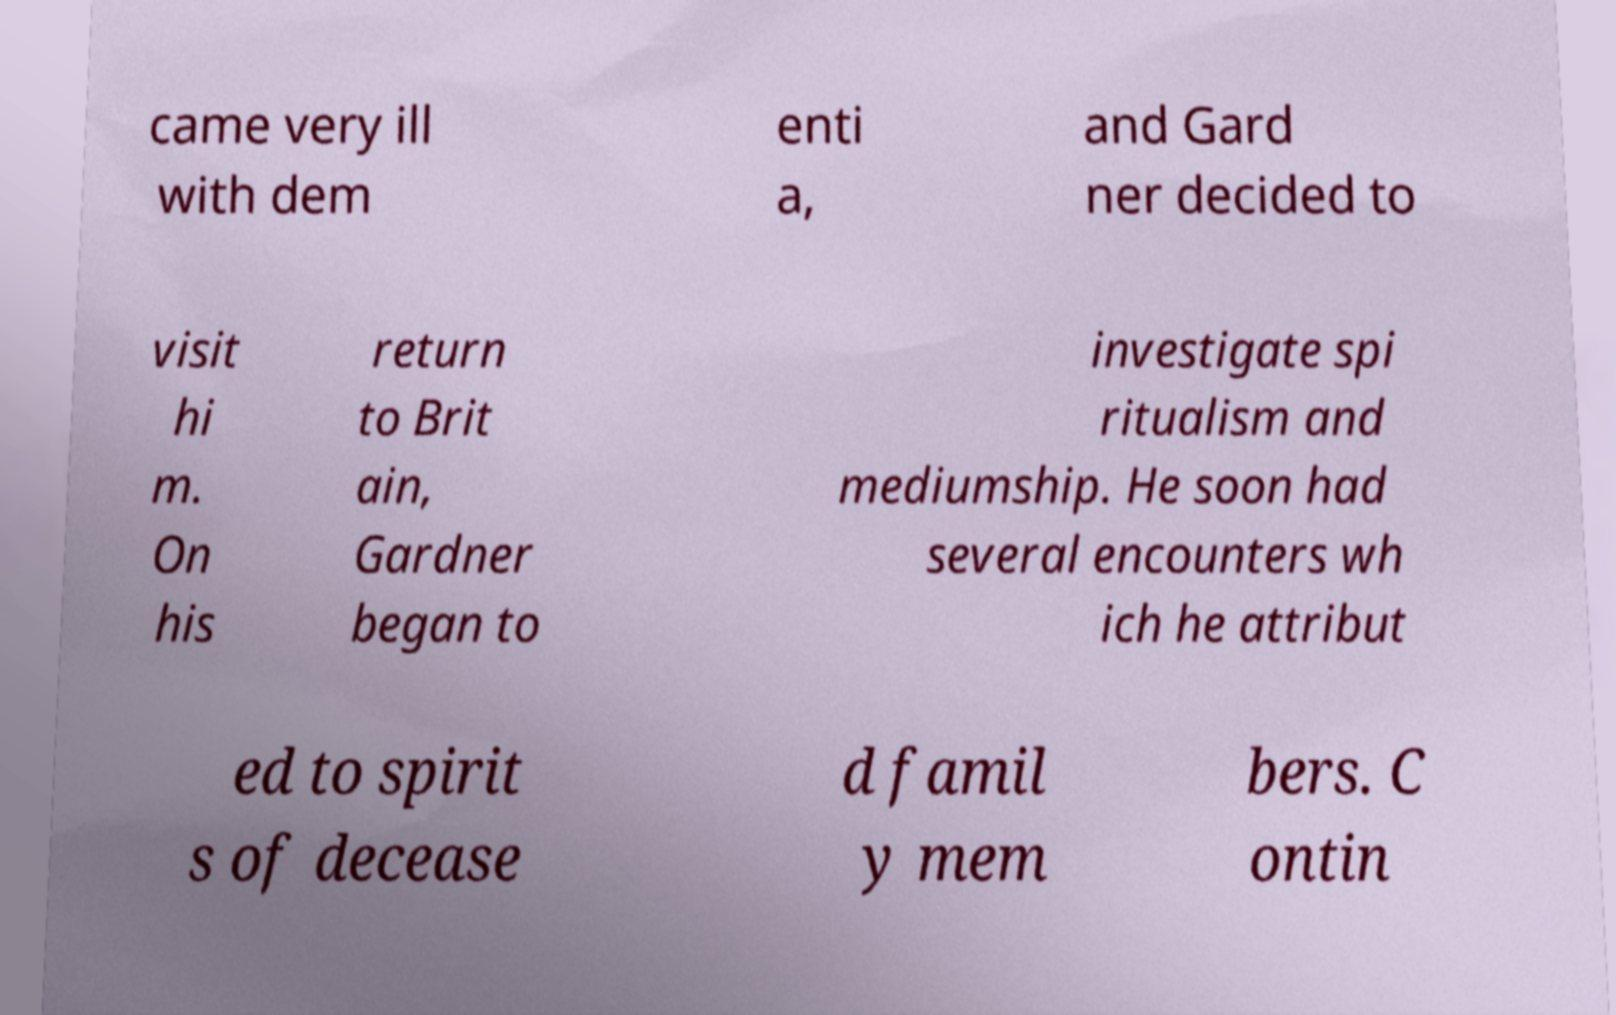For documentation purposes, I need the text within this image transcribed. Could you provide that? came very ill with dem enti a, and Gard ner decided to visit hi m. On his return to Brit ain, Gardner began to investigate spi ritualism and mediumship. He soon had several encounters wh ich he attribut ed to spirit s of decease d famil y mem bers. C ontin 